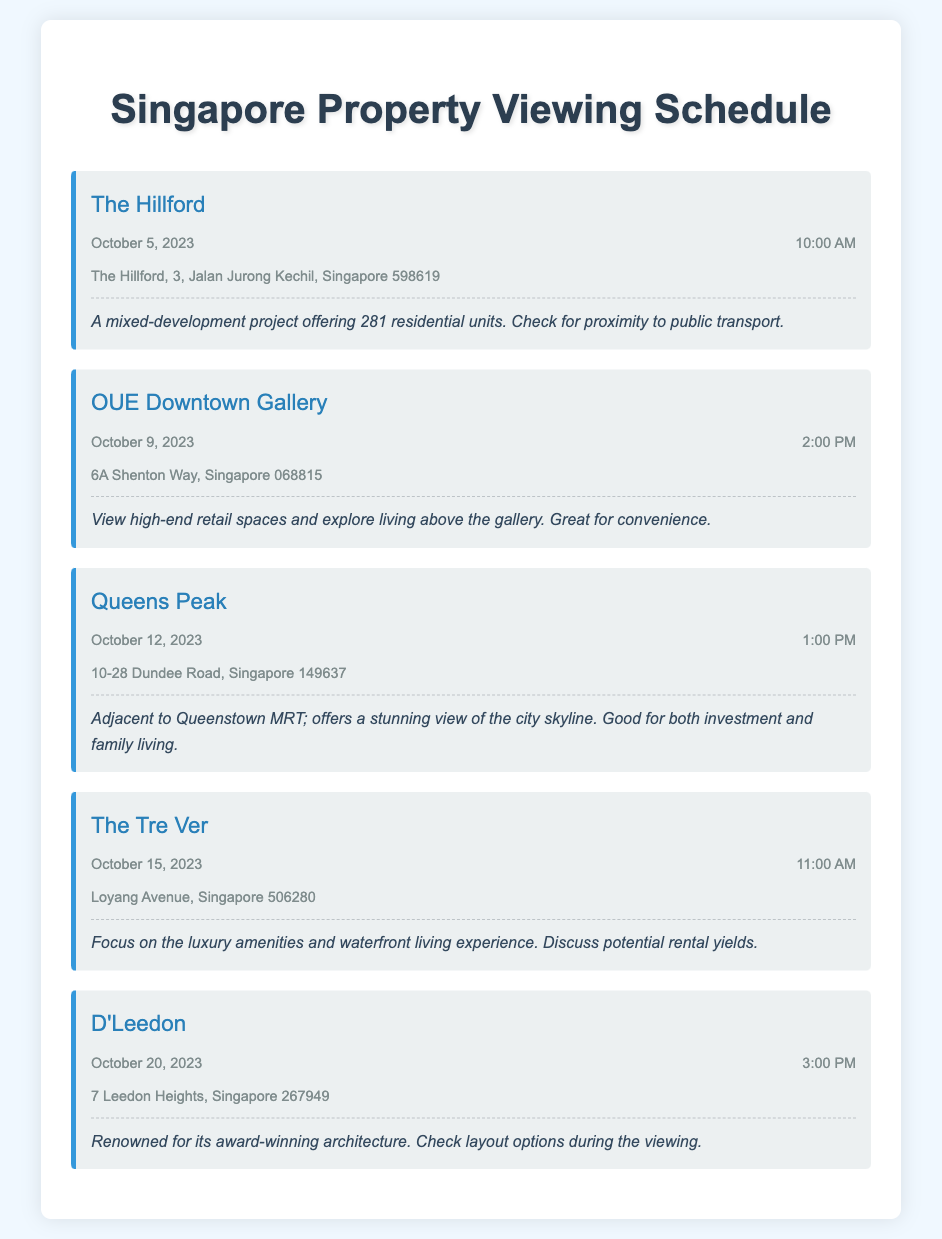What is the date of the property viewing for The Hillford? The date for The Hillford is explicitly mentioned in the document as October 5, 2023.
Answer: October 5, 2023 What time is the viewing for OUE Downtown Gallery? The time for the OUE Downtown Gallery viewing is given as 2:00 PM in the document.
Answer: 2:00 PM Where is Queens Peak located? The document specifies the location of Queens Peak as 10-28 Dundee Road, Singapore 149637.
Answer: 10-28 Dundee Road, Singapore 149637 What are the luxury amenities discussed for The Tre Ver? The notes for The Tre Ver mention a focus on luxury amenities, specifically highlighting the waterfront living experience.
Answer: Luxury amenities and waterfront living experience Which property is adjacent to Queenstown MRT? The document states that Queens Peak is adjacent to Queenstown MRT based on its notes.
Answer: Queens Peak How many residential units does The Hillford offer? The number of residential units offered by The Hillford is provided as 281 in the notes section.
Answer: 281 What is a notable feature of D'Leedon according to the document? The document mentions D'Leedon being renowned for its award-winning architecture.
Answer: Award-winning architecture Which viewing is scheduled for October 15, 2023? The viewing scheduled for October 15, 2023, is The Tre Ver according to the provided schedule.
Answer: The Tre Ver 